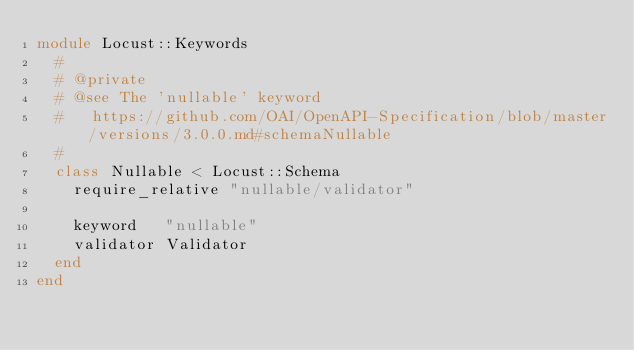<code> <loc_0><loc_0><loc_500><loc_500><_Ruby_>module Locust::Keywords
  #
  # @private
  # @see The 'nullable' keyword
  #   https://github.com/OAI/OpenAPI-Specification/blob/master/versions/3.0.0.md#schemaNullable
  #
  class Nullable < Locust::Schema
    require_relative "nullable/validator"

    keyword   "nullable"
    validator Validator
  end
end
</code> 